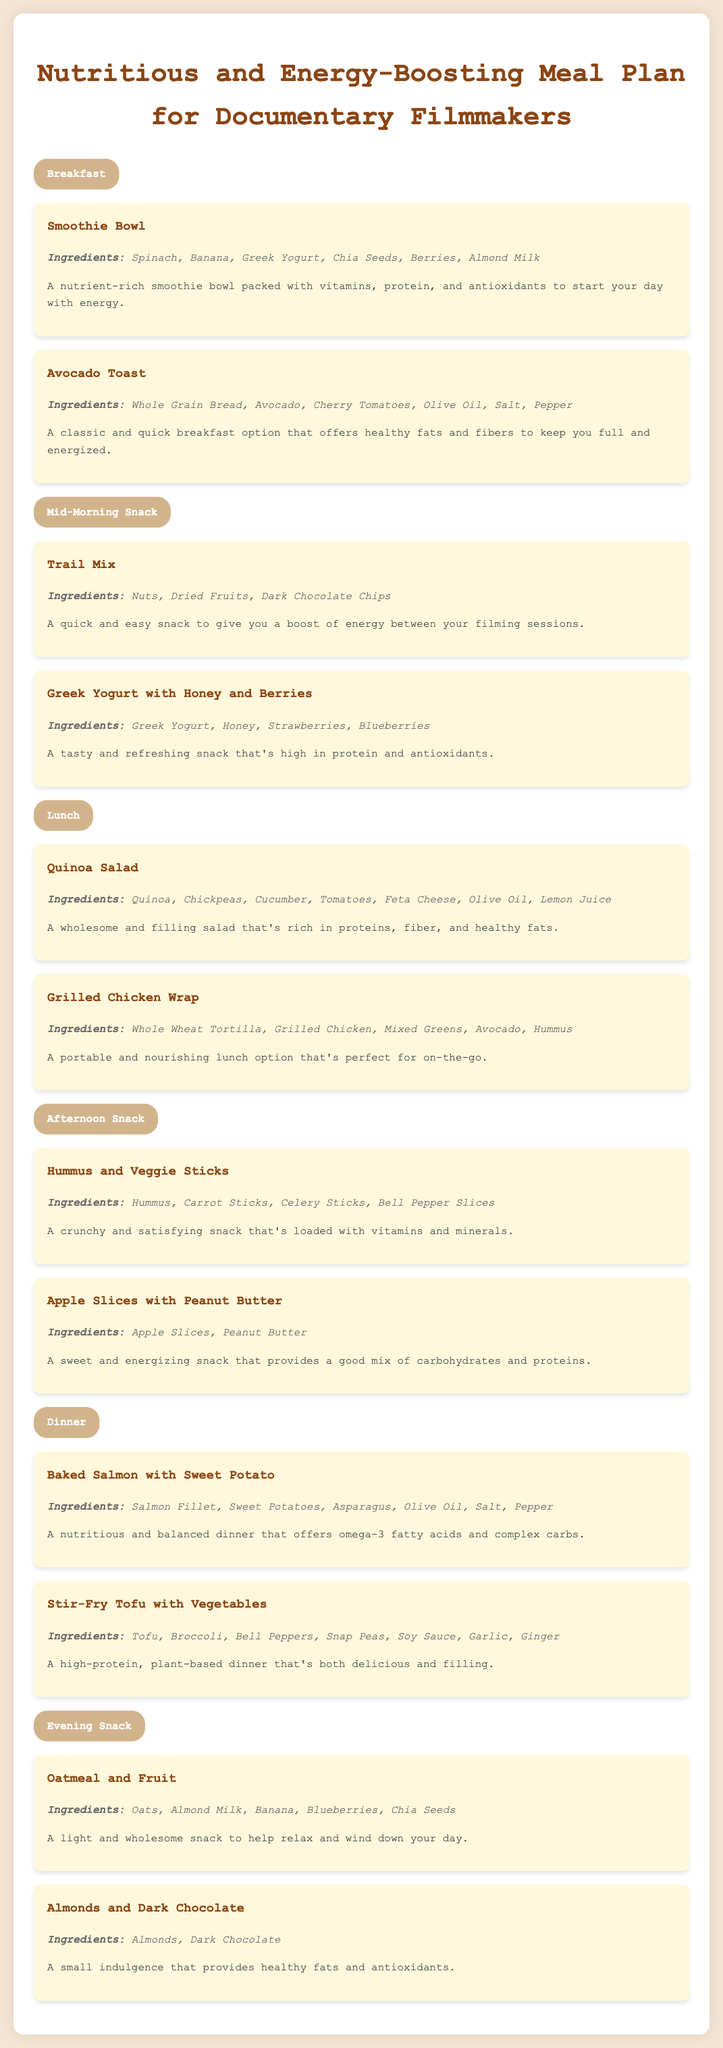What is the first breakfast item? The first breakfast item listed in the document is “Smoothie Bowl.”
Answer: Smoothie Bowl How many ingredients are in the Quinoa Salad? The ingredients for Quinoa Salad are listed as Quinoa, Chickpeas, Cucumber, Tomatoes, Feta Cheese, Olive Oil, Lemon Juice, totaling seven ingredients.
Answer: Seven What snack is recommended for mid-morning? The mid-morning snack listed is “Trail Mix.”
Answer: Trail Mix Which dinner option includes a fish? The dinner option that includes a fish is “Baked Salmon with Sweet Potato.”
Answer: Baked Salmon with Sweet Potato How many evening snacks are there? There are two evening snacks listed in the document: Oatmeal and Fruit, and Almonds and Dark Chocolate.
Answer: Two What is the main protein source in the Stir-Fry Tofu with Vegetables? The main protein source in the Stir-Fry Tofu with Vegetables is Tofu.
Answer: Tofu Which meal type offers a classic quick breakfast? The meal type that offers a classic quick breakfast is “Breakfast.”
Answer: Breakfast What is the main benefit mentioned for the Greek Yogurt with Honey and Berries? The main benefit mentioned for Greek Yogurt with Honey and Berries is that it is high in protein and antioxidants.
Answer: High in protein and antioxidants 